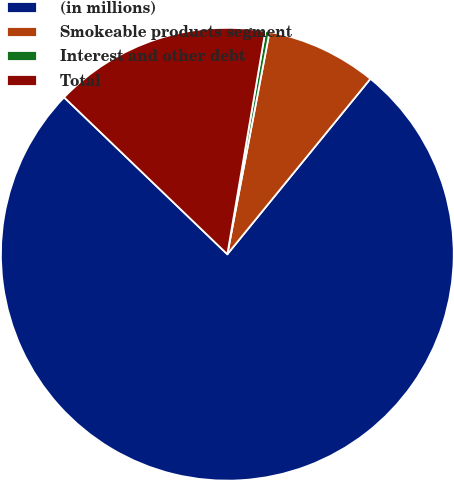Convert chart to OTSL. <chart><loc_0><loc_0><loc_500><loc_500><pie_chart><fcel>(in millions)<fcel>Smokeable products segment<fcel>Interest and other debt<fcel>Total<nl><fcel>76.29%<fcel>7.9%<fcel>0.3%<fcel>15.5%<nl></chart> 